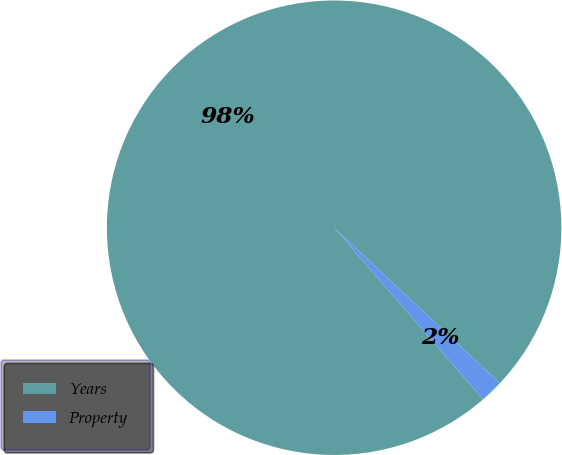<chart> <loc_0><loc_0><loc_500><loc_500><pie_chart><fcel>Years<fcel>Property<nl><fcel>98.36%<fcel>1.64%<nl></chart> 